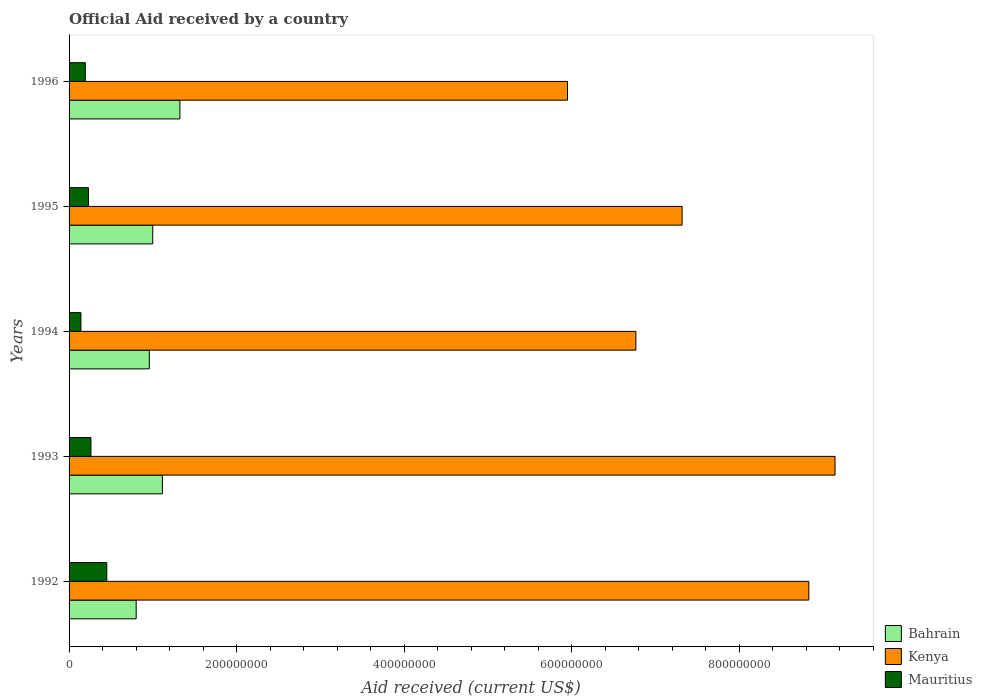How many groups of bars are there?
Give a very brief answer. 5. Are the number of bars per tick equal to the number of legend labels?
Make the answer very short. Yes. Are the number of bars on each tick of the Y-axis equal?
Ensure brevity in your answer.  Yes. How many bars are there on the 3rd tick from the bottom?
Offer a very short reply. 3. What is the net official aid received in Kenya in 1996?
Keep it short and to the point. 5.95e+08. Across all years, what is the maximum net official aid received in Bahrain?
Provide a succinct answer. 1.32e+08. Across all years, what is the minimum net official aid received in Kenya?
Provide a short and direct response. 5.95e+08. In which year was the net official aid received in Bahrain maximum?
Your answer should be compact. 1996. What is the total net official aid received in Bahrain in the graph?
Your response must be concise. 5.20e+08. What is the difference between the net official aid received in Kenya in 1994 and that in 1996?
Offer a very short reply. 8.16e+07. What is the difference between the net official aid received in Kenya in 1996 and the net official aid received in Mauritius in 1995?
Offer a terse response. 5.72e+08. What is the average net official aid received in Bahrain per year?
Ensure brevity in your answer.  1.04e+08. In the year 1992, what is the difference between the net official aid received in Bahrain and net official aid received in Mauritius?
Keep it short and to the point. 3.51e+07. In how many years, is the net official aid received in Mauritius greater than 200000000 US$?
Your response must be concise. 0. What is the ratio of the net official aid received in Bahrain in 1994 to that in 1996?
Offer a terse response. 0.72. Is the net official aid received in Mauritius in 1994 less than that in 1996?
Your response must be concise. Yes. Is the difference between the net official aid received in Bahrain in 1993 and 1994 greater than the difference between the net official aid received in Mauritius in 1993 and 1994?
Ensure brevity in your answer.  Yes. What is the difference between the highest and the second highest net official aid received in Bahrain?
Offer a terse response. 2.09e+07. What is the difference between the highest and the lowest net official aid received in Mauritius?
Offer a terse response. 3.09e+07. Is the sum of the net official aid received in Kenya in 1993 and 1995 greater than the maximum net official aid received in Mauritius across all years?
Provide a succinct answer. Yes. What does the 1st bar from the top in 1992 represents?
Provide a short and direct response. Mauritius. What does the 3rd bar from the bottom in 1995 represents?
Your response must be concise. Mauritius. Is it the case that in every year, the sum of the net official aid received in Mauritius and net official aid received in Bahrain is greater than the net official aid received in Kenya?
Keep it short and to the point. No. How many bars are there?
Provide a short and direct response. 15. How many years are there in the graph?
Provide a succinct answer. 5. What is the difference between two consecutive major ticks on the X-axis?
Your answer should be very brief. 2.00e+08. Are the values on the major ticks of X-axis written in scientific E-notation?
Keep it short and to the point. No. Where does the legend appear in the graph?
Give a very brief answer. Bottom right. What is the title of the graph?
Keep it short and to the point. Official Aid received by a country. What is the label or title of the X-axis?
Offer a very short reply. Aid received (current US$). What is the Aid received (current US$) of Bahrain in 1992?
Your response must be concise. 8.01e+07. What is the Aid received (current US$) in Kenya in 1992?
Give a very brief answer. 8.83e+08. What is the Aid received (current US$) in Mauritius in 1992?
Your answer should be compact. 4.50e+07. What is the Aid received (current US$) of Bahrain in 1993?
Your response must be concise. 1.11e+08. What is the Aid received (current US$) in Kenya in 1993?
Give a very brief answer. 9.14e+08. What is the Aid received (current US$) in Mauritius in 1993?
Provide a short and direct response. 2.61e+07. What is the Aid received (current US$) in Bahrain in 1994?
Provide a short and direct response. 9.58e+07. What is the Aid received (current US$) in Kenya in 1994?
Give a very brief answer. 6.77e+08. What is the Aid received (current US$) in Mauritius in 1994?
Keep it short and to the point. 1.41e+07. What is the Aid received (current US$) in Bahrain in 1995?
Your response must be concise. 9.99e+07. What is the Aid received (current US$) in Kenya in 1995?
Provide a succinct answer. 7.32e+08. What is the Aid received (current US$) of Mauritius in 1995?
Your response must be concise. 2.31e+07. What is the Aid received (current US$) in Bahrain in 1996?
Give a very brief answer. 1.32e+08. What is the Aid received (current US$) of Kenya in 1996?
Your answer should be very brief. 5.95e+08. What is the Aid received (current US$) in Mauritius in 1996?
Your answer should be compact. 1.94e+07. Across all years, what is the maximum Aid received (current US$) of Bahrain?
Ensure brevity in your answer.  1.32e+08. Across all years, what is the maximum Aid received (current US$) of Kenya?
Give a very brief answer. 9.14e+08. Across all years, what is the maximum Aid received (current US$) of Mauritius?
Make the answer very short. 4.50e+07. Across all years, what is the minimum Aid received (current US$) in Bahrain?
Offer a terse response. 8.01e+07. Across all years, what is the minimum Aid received (current US$) of Kenya?
Offer a very short reply. 5.95e+08. Across all years, what is the minimum Aid received (current US$) of Mauritius?
Your response must be concise. 1.41e+07. What is the total Aid received (current US$) in Bahrain in the graph?
Provide a short and direct response. 5.20e+08. What is the total Aid received (current US$) of Kenya in the graph?
Your answer should be compact. 3.80e+09. What is the total Aid received (current US$) of Mauritius in the graph?
Provide a short and direct response. 1.28e+08. What is the difference between the Aid received (current US$) of Bahrain in 1992 and that in 1993?
Make the answer very short. -3.13e+07. What is the difference between the Aid received (current US$) in Kenya in 1992 and that in 1993?
Your response must be concise. -3.12e+07. What is the difference between the Aid received (current US$) of Mauritius in 1992 and that in 1993?
Offer a terse response. 1.90e+07. What is the difference between the Aid received (current US$) of Bahrain in 1992 and that in 1994?
Offer a terse response. -1.57e+07. What is the difference between the Aid received (current US$) in Kenya in 1992 and that in 1994?
Ensure brevity in your answer.  2.07e+08. What is the difference between the Aid received (current US$) of Mauritius in 1992 and that in 1994?
Offer a very short reply. 3.09e+07. What is the difference between the Aid received (current US$) of Bahrain in 1992 and that in 1995?
Your answer should be very brief. -1.98e+07. What is the difference between the Aid received (current US$) in Kenya in 1992 and that in 1995?
Ensure brevity in your answer.  1.51e+08. What is the difference between the Aid received (current US$) of Mauritius in 1992 and that in 1995?
Offer a terse response. 2.19e+07. What is the difference between the Aid received (current US$) in Bahrain in 1992 and that in 1996?
Offer a terse response. -5.22e+07. What is the difference between the Aid received (current US$) of Kenya in 1992 and that in 1996?
Your response must be concise. 2.88e+08. What is the difference between the Aid received (current US$) in Mauritius in 1992 and that in 1996?
Your response must be concise. 2.56e+07. What is the difference between the Aid received (current US$) of Bahrain in 1993 and that in 1994?
Ensure brevity in your answer.  1.56e+07. What is the difference between the Aid received (current US$) of Kenya in 1993 and that in 1994?
Offer a very short reply. 2.38e+08. What is the difference between the Aid received (current US$) in Mauritius in 1993 and that in 1994?
Your answer should be compact. 1.19e+07. What is the difference between the Aid received (current US$) in Bahrain in 1993 and that in 1995?
Your response must be concise. 1.16e+07. What is the difference between the Aid received (current US$) of Kenya in 1993 and that in 1995?
Give a very brief answer. 1.83e+08. What is the difference between the Aid received (current US$) in Mauritius in 1993 and that in 1995?
Provide a short and direct response. 2.96e+06. What is the difference between the Aid received (current US$) of Bahrain in 1993 and that in 1996?
Provide a short and direct response. -2.09e+07. What is the difference between the Aid received (current US$) of Kenya in 1993 and that in 1996?
Provide a short and direct response. 3.19e+08. What is the difference between the Aid received (current US$) of Mauritius in 1993 and that in 1996?
Provide a short and direct response. 6.69e+06. What is the difference between the Aid received (current US$) in Bahrain in 1994 and that in 1995?
Your response must be concise. -4.08e+06. What is the difference between the Aid received (current US$) in Kenya in 1994 and that in 1995?
Make the answer very short. -5.52e+07. What is the difference between the Aid received (current US$) in Mauritius in 1994 and that in 1995?
Your answer should be very brief. -8.98e+06. What is the difference between the Aid received (current US$) in Bahrain in 1994 and that in 1996?
Give a very brief answer. -3.65e+07. What is the difference between the Aid received (current US$) in Kenya in 1994 and that in 1996?
Keep it short and to the point. 8.16e+07. What is the difference between the Aid received (current US$) in Mauritius in 1994 and that in 1996?
Your response must be concise. -5.25e+06. What is the difference between the Aid received (current US$) of Bahrain in 1995 and that in 1996?
Offer a very short reply. -3.24e+07. What is the difference between the Aid received (current US$) in Kenya in 1995 and that in 1996?
Make the answer very short. 1.37e+08. What is the difference between the Aid received (current US$) in Mauritius in 1995 and that in 1996?
Provide a short and direct response. 3.73e+06. What is the difference between the Aid received (current US$) in Bahrain in 1992 and the Aid received (current US$) in Kenya in 1993?
Your response must be concise. -8.34e+08. What is the difference between the Aid received (current US$) in Bahrain in 1992 and the Aid received (current US$) in Mauritius in 1993?
Offer a terse response. 5.40e+07. What is the difference between the Aid received (current US$) in Kenya in 1992 and the Aid received (current US$) in Mauritius in 1993?
Give a very brief answer. 8.57e+08. What is the difference between the Aid received (current US$) in Bahrain in 1992 and the Aid received (current US$) in Kenya in 1994?
Keep it short and to the point. -5.97e+08. What is the difference between the Aid received (current US$) of Bahrain in 1992 and the Aid received (current US$) of Mauritius in 1994?
Your answer should be compact. 6.60e+07. What is the difference between the Aid received (current US$) in Kenya in 1992 and the Aid received (current US$) in Mauritius in 1994?
Provide a succinct answer. 8.69e+08. What is the difference between the Aid received (current US$) in Bahrain in 1992 and the Aid received (current US$) in Kenya in 1995?
Ensure brevity in your answer.  -6.52e+08. What is the difference between the Aid received (current US$) in Bahrain in 1992 and the Aid received (current US$) in Mauritius in 1995?
Make the answer very short. 5.70e+07. What is the difference between the Aid received (current US$) of Kenya in 1992 and the Aid received (current US$) of Mauritius in 1995?
Provide a succinct answer. 8.60e+08. What is the difference between the Aid received (current US$) in Bahrain in 1992 and the Aid received (current US$) in Kenya in 1996?
Give a very brief answer. -5.15e+08. What is the difference between the Aid received (current US$) of Bahrain in 1992 and the Aid received (current US$) of Mauritius in 1996?
Offer a very short reply. 6.07e+07. What is the difference between the Aid received (current US$) in Kenya in 1992 and the Aid received (current US$) in Mauritius in 1996?
Provide a short and direct response. 8.64e+08. What is the difference between the Aid received (current US$) of Bahrain in 1993 and the Aid received (current US$) of Kenya in 1994?
Your answer should be very brief. -5.65e+08. What is the difference between the Aid received (current US$) in Bahrain in 1993 and the Aid received (current US$) in Mauritius in 1994?
Offer a very short reply. 9.73e+07. What is the difference between the Aid received (current US$) of Kenya in 1993 and the Aid received (current US$) of Mauritius in 1994?
Offer a terse response. 9.00e+08. What is the difference between the Aid received (current US$) of Bahrain in 1993 and the Aid received (current US$) of Kenya in 1995?
Provide a succinct answer. -6.20e+08. What is the difference between the Aid received (current US$) in Bahrain in 1993 and the Aid received (current US$) in Mauritius in 1995?
Give a very brief answer. 8.83e+07. What is the difference between the Aid received (current US$) of Kenya in 1993 and the Aid received (current US$) of Mauritius in 1995?
Keep it short and to the point. 8.91e+08. What is the difference between the Aid received (current US$) in Bahrain in 1993 and the Aid received (current US$) in Kenya in 1996?
Offer a very short reply. -4.84e+08. What is the difference between the Aid received (current US$) in Bahrain in 1993 and the Aid received (current US$) in Mauritius in 1996?
Make the answer very short. 9.20e+07. What is the difference between the Aid received (current US$) of Kenya in 1993 and the Aid received (current US$) of Mauritius in 1996?
Your response must be concise. 8.95e+08. What is the difference between the Aid received (current US$) in Bahrain in 1994 and the Aid received (current US$) in Kenya in 1995?
Provide a short and direct response. -6.36e+08. What is the difference between the Aid received (current US$) of Bahrain in 1994 and the Aid received (current US$) of Mauritius in 1995?
Offer a terse response. 7.27e+07. What is the difference between the Aid received (current US$) in Kenya in 1994 and the Aid received (current US$) in Mauritius in 1995?
Offer a terse response. 6.54e+08. What is the difference between the Aid received (current US$) of Bahrain in 1994 and the Aid received (current US$) of Kenya in 1996?
Make the answer very short. -4.99e+08. What is the difference between the Aid received (current US$) of Bahrain in 1994 and the Aid received (current US$) of Mauritius in 1996?
Your answer should be compact. 7.64e+07. What is the difference between the Aid received (current US$) of Kenya in 1994 and the Aid received (current US$) of Mauritius in 1996?
Your answer should be compact. 6.57e+08. What is the difference between the Aid received (current US$) in Bahrain in 1995 and the Aid received (current US$) in Kenya in 1996?
Make the answer very short. -4.95e+08. What is the difference between the Aid received (current US$) of Bahrain in 1995 and the Aid received (current US$) of Mauritius in 1996?
Ensure brevity in your answer.  8.05e+07. What is the difference between the Aid received (current US$) in Kenya in 1995 and the Aid received (current US$) in Mauritius in 1996?
Your response must be concise. 7.12e+08. What is the average Aid received (current US$) of Bahrain per year?
Your response must be concise. 1.04e+08. What is the average Aid received (current US$) of Kenya per year?
Give a very brief answer. 7.60e+08. What is the average Aid received (current US$) of Mauritius per year?
Provide a short and direct response. 2.56e+07. In the year 1992, what is the difference between the Aid received (current US$) in Bahrain and Aid received (current US$) in Kenya?
Ensure brevity in your answer.  -8.03e+08. In the year 1992, what is the difference between the Aid received (current US$) of Bahrain and Aid received (current US$) of Mauritius?
Keep it short and to the point. 3.51e+07. In the year 1992, what is the difference between the Aid received (current US$) in Kenya and Aid received (current US$) in Mauritius?
Provide a short and direct response. 8.38e+08. In the year 1993, what is the difference between the Aid received (current US$) in Bahrain and Aid received (current US$) in Kenya?
Offer a very short reply. -8.03e+08. In the year 1993, what is the difference between the Aid received (current US$) in Bahrain and Aid received (current US$) in Mauritius?
Give a very brief answer. 8.54e+07. In the year 1993, what is the difference between the Aid received (current US$) in Kenya and Aid received (current US$) in Mauritius?
Ensure brevity in your answer.  8.88e+08. In the year 1994, what is the difference between the Aid received (current US$) in Bahrain and Aid received (current US$) in Kenya?
Your answer should be compact. -5.81e+08. In the year 1994, what is the difference between the Aid received (current US$) of Bahrain and Aid received (current US$) of Mauritius?
Offer a terse response. 8.16e+07. In the year 1994, what is the difference between the Aid received (current US$) of Kenya and Aid received (current US$) of Mauritius?
Keep it short and to the point. 6.62e+08. In the year 1995, what is the difference between the Aid received (current US$) in Bahrain and Aid received (current US$) in Kenya?
Keep it short and to the point. -6.32e+08. In the year 1995, what is the difference between the Aid received (current US$) of Bahrain and Aid received (current US$) of Mauritius?
Provide a succinct answer. 7.68e+07. In the year 1995, what is the difference between the Aid received (current US$) in Kenya and Aid received (current US$) in Mauritius?
Keep it short and to the point. 7.09e+08. In the year 1996, what is the difference between the Aid received (current US$) of Bahrain and Aid received (current US$) of Kenya?
Make the answer very short. -4.63e+08. In the year 1996, what is the difference between the Aid received (current US$) in Bahrain and Aid received (current US$) in Mauritius?
Make the answer very short. 1.13e+08. In the year 1996, what is the difference between the Aid received (current US$) of Kenya and Aid received (current US$) of Mauritius?
Ensure brevity in your answer.  5.76e+08. What is the ratio of the Aid received (current US$) of Bahrain in 1992 to that in 1993?
Provide a short and direct response. 0.72. What is the ratio of the Aid received (current US$) of Kenya in 1992 to that in 1993?
Your response must be concise. 0.97. What is the ratio of the Aid received (current US$) in Mauritius in 1992 to that in 1993?
Offer a very short reply. 1.73. What is the ratio of the Aid received (current US$) of Bahrain in 1992 to that in 1994?
Provide a short and direct response. 0.84. What is the ratio of the Aid received (current US$) of Kenya in 1992 to that in 1994?
Ensure brevity in your answer.  1.31. What is the ratio of the Aid received (current US$) in Mauritius in 1992 to that in 1994?
Make the answer very short. 3.18. What is the ratio of the Aid received (current US$) in Bahrain in 1992 to that in 1995?
Offer a very short reply. 0.8. What is the ratio of the Aid received (current US$) of Kenya in 1992 to that in 1995?
Your response must be concise. 1.21. What is the ratio of the Aid received (current US$) in Mauritius in 1992 to that in 1995?
Your response must be concise. 1.95. What is the ratio of the Aid received (current US$) in Bahrain in 1992 to that in 1996?
Offer a terse response. 0.61. What is the ratio of the Aid received (current US$) in Kenya in 1992 to that in 1996?
Provide a short and direct response. 1.48. What is the ratio of the Aid received (current US$) in Mauritius in 1992 to that in 1996?
Make the answer very short. 2.32. What is the ratio of the Aid received (current US$) of Bahrain in 1993 to that in 1994?
Make the answer very short. 1.16. What is the ratio of the Aid received (current US$) in Kenya in 1993 to that in 1994?
Your response must be concise. 1.35. What is the ratio of the Aid received (current US$) of Mauritius in 1993 to that in 1994?
Offer a very short reply. 1.84. What is the ratio of the Aid received (current US$) in Bahrain in 1993 to that in 1995?
Make the answer very short. 1.12. What is the ratio of the Aid received (current US$) of Kenya in 1993 to that in 1995?
Your answer should be compact. 1.25. What is the ratio of the Aid received (current US$) of Mauritius in 1993 to that in 1995?
Keep it short and to the point. 1.13. What is the ratio of the Aid received (current US$) of Bahrain in 1993 to that in 1996?
Your answer should be very brief. 0.84. What is the ratio of the Aid received (current US$) of Kenya in 1993 to that in 1996?
Provide a short and direct response. 1.54. What is the ratio of the Aid received (current US$) of Mauritius in 1993 to that in 1996?
Make the answer very short. 1.34. What is the ratio of the Aid received (current US$) of Bahrain in 1994 to that in 1995?
Give a very brief answer. 0.96. What is the ratio of the Aid received (current US$) of Kenya in 1994 to that in 1995?
Offer a very short reply. 0.92. What is the ratio of the Aid received (current US$) of Mauritius in 1994 to that in 1995?
Give a very brief answer. 0.61. What is the ratio of the Aid received (current US$) in Bahrain in 1994 to that in 1996?
Your response must be concise. 0.72. What is the ratio of the Aid received (current US$) in Kenya in 1994 to that in 1996?
Provide a short and direct response. 1.14. What is the ratio of the Aid received (current US$) in Mauritius in 1994 to that in 1996?
Give a very brief answer. 0.73. What is the ratio of the Aid received (current US$) in Bahrain in 1995 to that in 1996?
Offer a terse response. 0.75. What is the ratio of the Aid received (current US$) of Kenya in 1995 to that in 1996?
Your answer should be compact. 1.23. What is the ratio of the Aid received (current US$) in Mauritius in 1995 to that in 1996?
Offer a very short reply. 1.19. What is the difference between the highest and the second highest Aid received (current US$) in Bahrain?
Offer a very short reply. 2.09e+07. What is the difference between the highest and the second highest Aid received (current US$) in Kenya?
Provide a succinct answer. 3.12e+07. What is the difference between the highest and the second highest Aid received (current US$) of Mauritius?
Make the answer very short. 1.90e+07. What is the difference between the highest and the lowest Aid received (current US$) in Bahrain?
Offer a terse response. 5.22e+07. What is the difference between the highest and the lowest Aid received (current US$) in Kenya?
Keep it short and to the point. 3.19e+08. What is the difference between the highest and the lowest Aid received (current US$) of Mauritius?
Ensure brevity in your answer.  3.09e+07. 